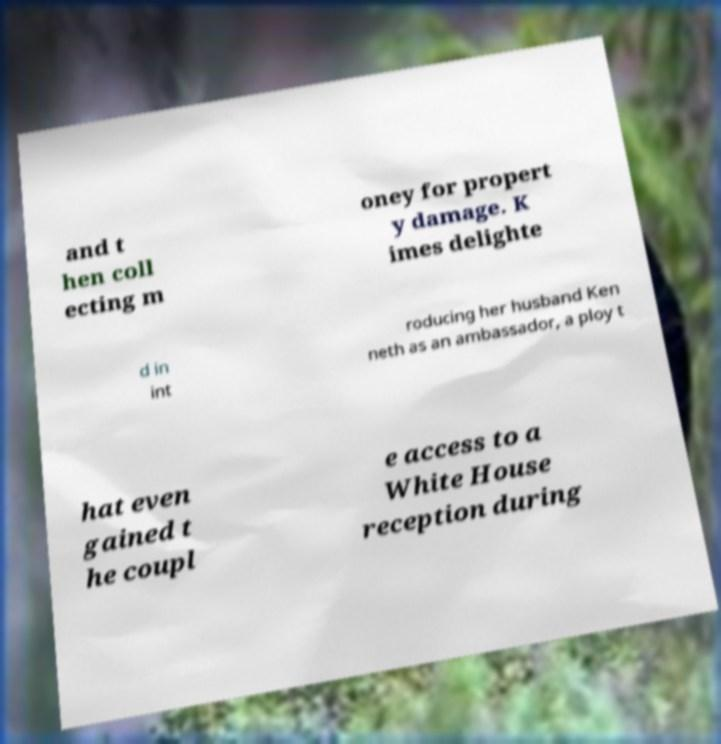Can you accurately transcribe the text from the provided image for me? and t hen coll ecting m oney for propert y damage. K imes delighte d in int roducing her husband Ken neth as an ambassador, a ploy t hat even gained t he coupl e access to a White House reception during 